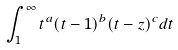<formula> <loc_0><loc_0><loc_500><loc_500>\int _ { 1 } ^ { \infty } t ^ { a } ( t - 1 ) ^ { b } ( t - z ) ^ { c } d t</formula> 